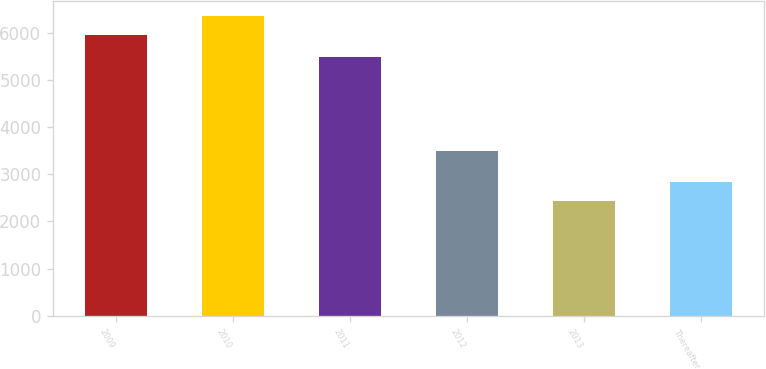Convert chart to OTSL. <chart><loc_0><loc_0><loc_500><loc_500><bar_chart><fcel>2009<fcel>2010<fcel>2011<fcel>2012<fcel>2013<fcel>Thereafter<nl><fcel>5948<fcel>6348<fcel>5475<fcel>3488<fcel>2442<fcel>2832.6<nl></chart> 